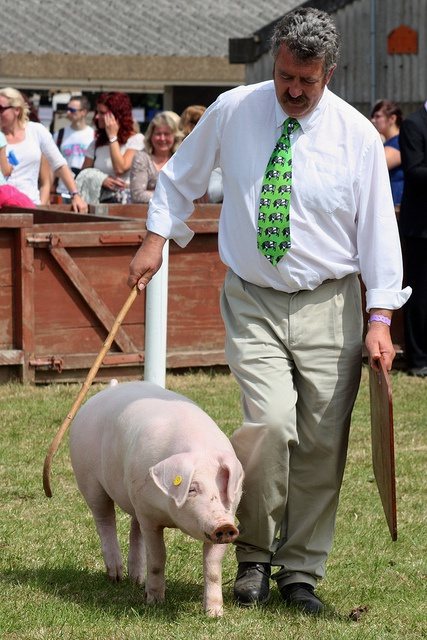Describe the objects in this image and their specific colors. I can see people in darkgray, lightgray, gray, and black tones, people in darkgray, black, gray, and white tones, people in darkgray, lavender, lightpink, brown, and violet tones, people in darkgray, black, maroon, and lightgray tones, and tie in darkgray, green, lightgreen, black, and gray tones in this image. 